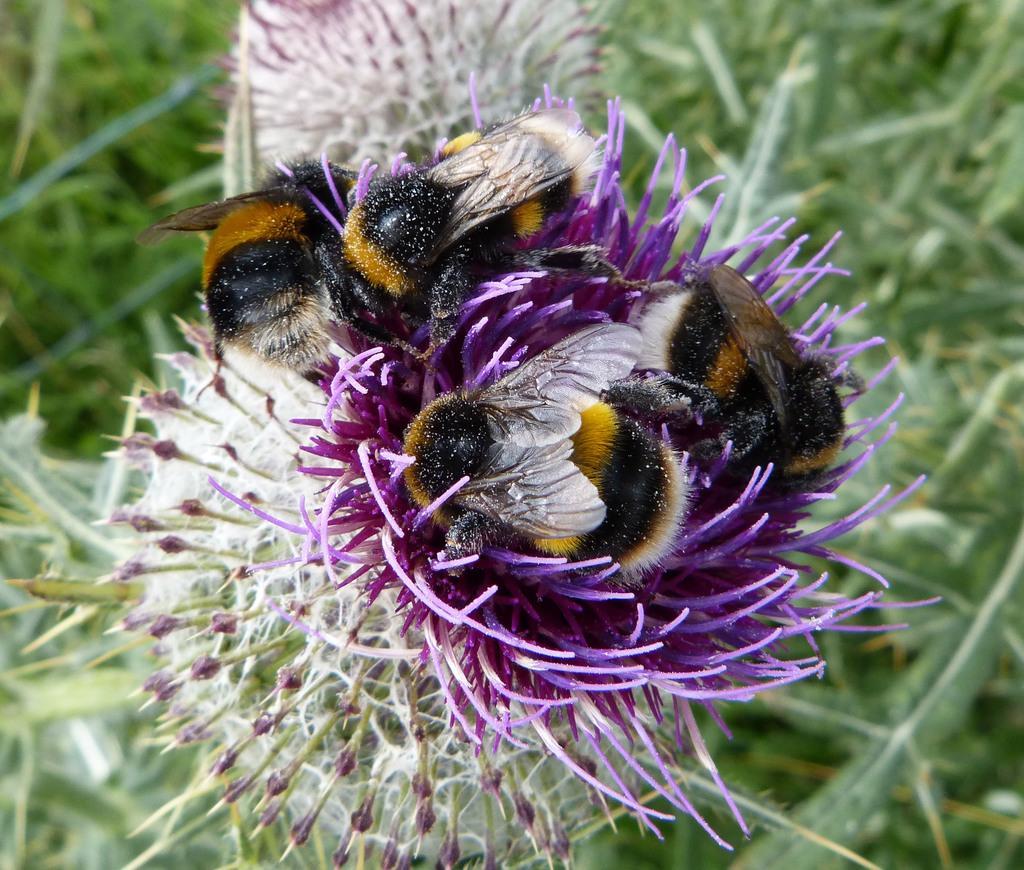How would you summarize this image in a sentence or two? In this image there are flowers. There are four honey bees on a flower. Around the flowers there is grass in the image. 